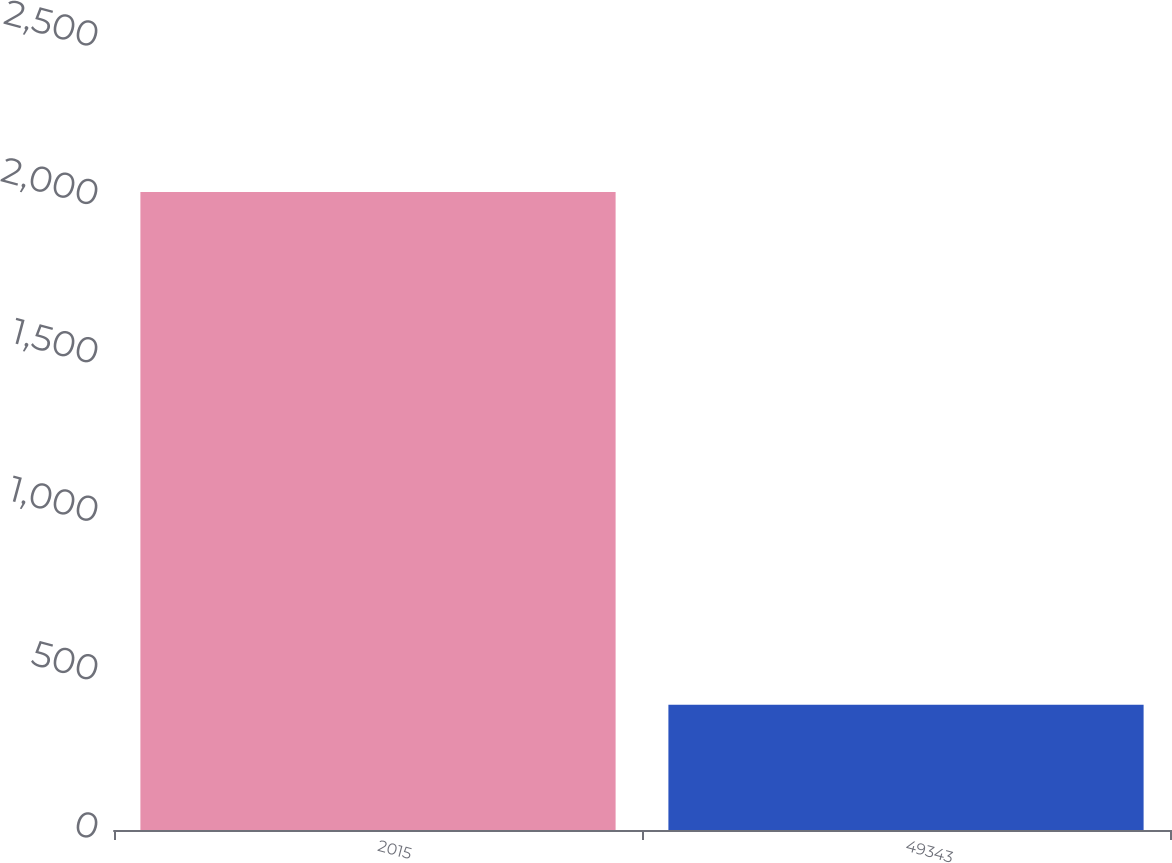<chart> <loc_0><loc_0><loc_500><loc_500><bar_chart><fcel>2015<fcel>49343<nl><fcel>2014<fcel>395.22<nl></chart> 